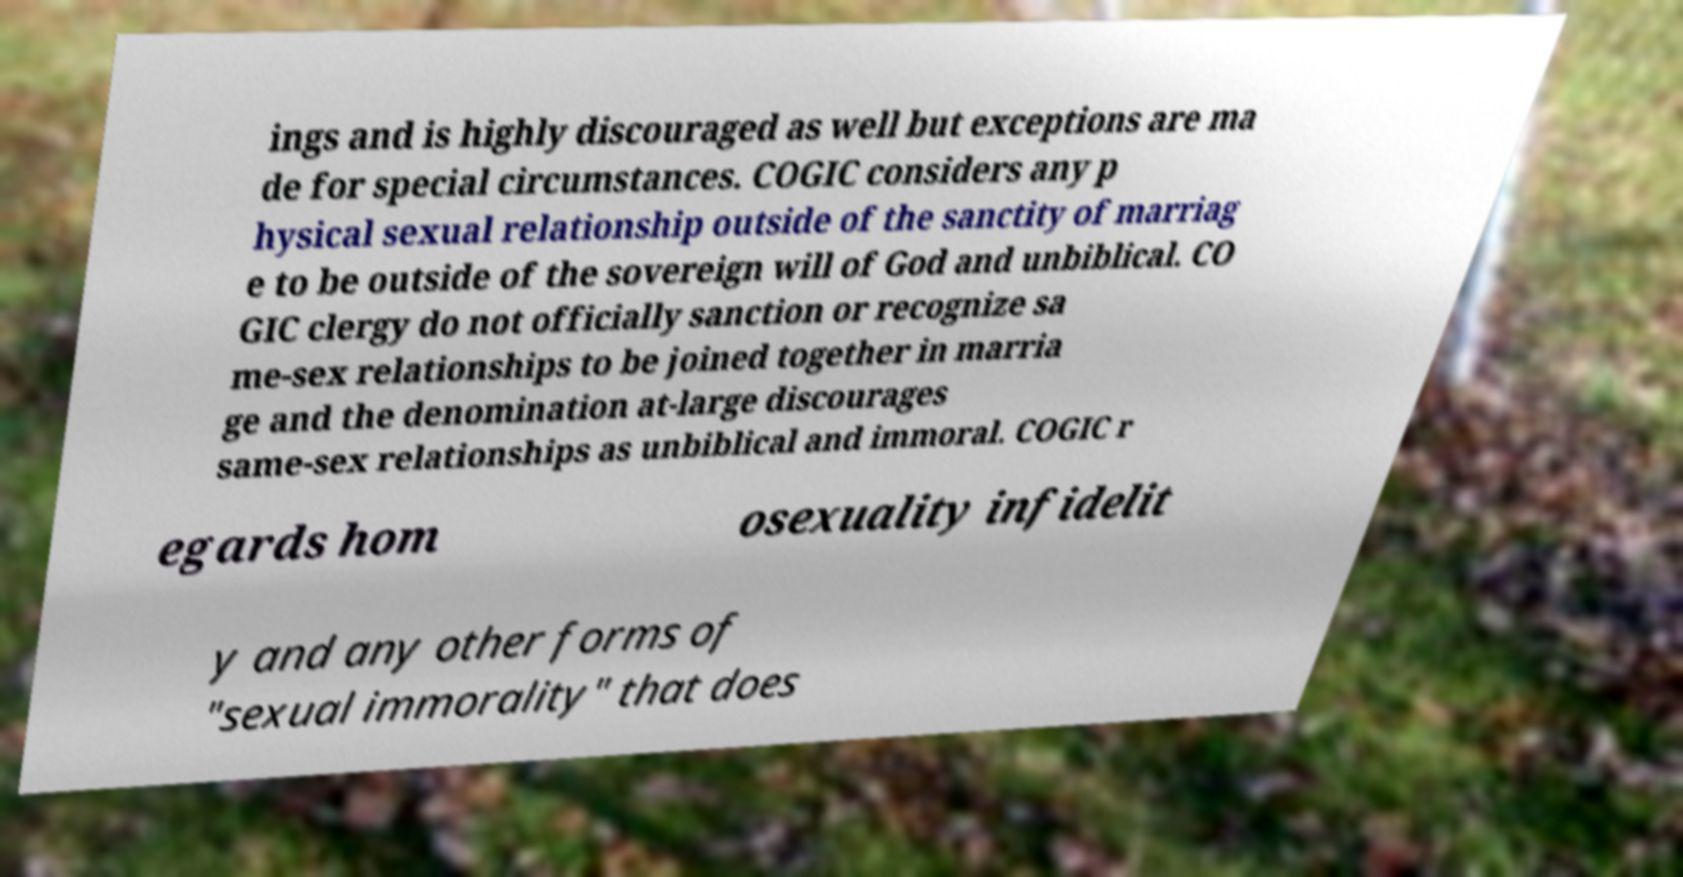Can you accurately transcribe the text from the provided image for me? ings and is highly discouraged as well but exceptions are ma de for special circumstances. COGIC considers any p hysical sexual relationship outside of the sanctity of marriag e to be outside of the sovereign will of God and unbiblical. CO GIC clergy do not officially sanction or recognize sa me-sex relationships to be joined together in marria ge and the denomination at-large discourages same-sex relationships as unbiblical and immoral. COGIC r egards hom osexuality infidelit y and any other forms of "sexual immorality" that does 